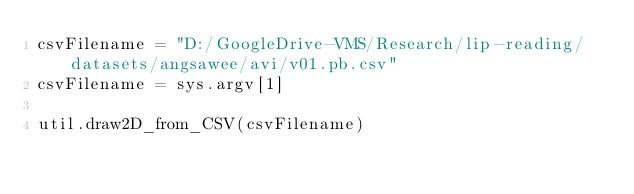<code> <loc_0><loc_0><loc_500><loc_500><_Python_>csvFilename = "D:/GoogleDrive-VMS/Research/lip-reading/datasets/angsawee/avi/v01.pb.csv"
csvFilename = sys.argv[1]

util.draw2D_from_CSV(csvFilename)
</code> 